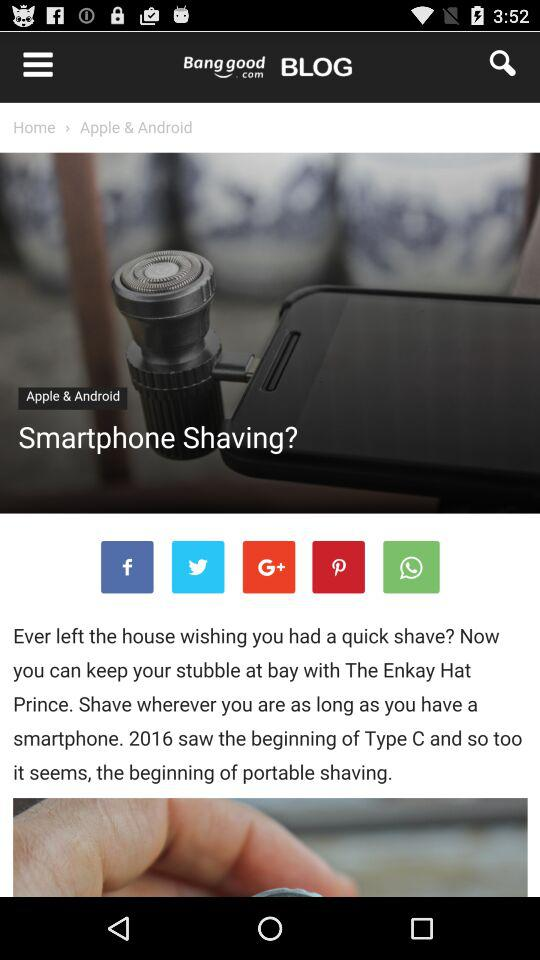What is the selected option in "Clothing and Apparel" Category? The selected option is "Bottoms". 